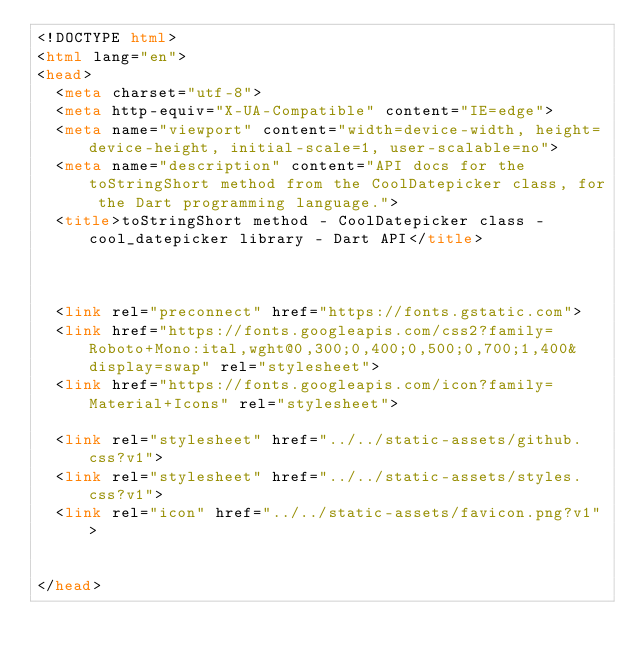Convert code to text. <code><loc_0><loc_0><loc_500><loc_500><_HTML_><!DOCTYPE html>
<html lang="en">
<head>
  <meta charset="utf-8">
  <meta http-equiv="X-UA-Compatible" content="IE=edge">
  <meta name="viewport" content="width=device-width, height=device-height, initial-scale=1, user-scalable=no">
  <meta name="description" content="API docs for the toStringShort method from the CoolDatepicker class, for the Dart programming language.">
  <title>toStringShort method - CoolDatepicker class - cool_datepicker library - Dart API</title>


  
  <link rel="preconnect" href="https://fonts.gstatic.com">
  <link href="https://fonts.googleapis.com/css2?family=Roboto+Mono:ital,wght@0,300;0,400;0,500;0,700;1,400&display=swap" rel="stylesheet">
  <link href="https://fonts.googleapis.com/icon?family=Material+Icons" rel="stylesheet">
  
  <link rel="stylesheet" href="../../static-assets/github.css?v1">
  <link rel="stylesheet" href="../../static-assets/styles.css?v1">
  <link rel="icon" href="../../static-assets/favicon.png?v1">

  
</head>

</code> 